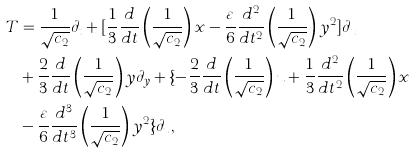Convert formula to latex. <formula><loc_0><loc_0><loc_500><loc_500>T & = \frac { 1 } { { \sqrt { c _ { 2 } } } } \partial _ { t } + [ \frac { 1 } { 3 } \frac { d } { d t } \left ( { \frac { 1 } { { \sqrt { c _ { 2 } } } } } \right ) x - \frac { \varepsilon } { 6 } \frac { d ^ { 2 } } { d t ^ { 2 } } \left ( { \frac { 1 } { { \sqrt { c _ { 2 } } } } } \right ) y ^ { 2 } ] \partial _ { x } \\ & + \frac { 2 } { 3 } \frac { d } { d t } \left ( { \frac { 1 } { { \sqrt { c _ { 2 } } } } } \right ) y \partial _ { y } + \{ - \frac { 2 } { 3 } \frac { d } { d t } \left ( { \frac { 1 } { { \sqrt { c _ { 2 } } } } } \right ) u + \frac { 1 } { 3 } \frac { d ^ { 2 } } { d t ^ { 2 } } \left ( { \frac { 1 } { { \sqrt { c _ { 2 } } } } } \right ) x \\ & - \frac { \varepsilon } { 6 } \frac { d ^ { 3 } } { d t ^ { 3 } } \left ( { \frac { 1 } { { \sqrt { c _ { 2 } } } } } \right ) y ^ { 2 } \} \partial _ { u } , \\</formula> 